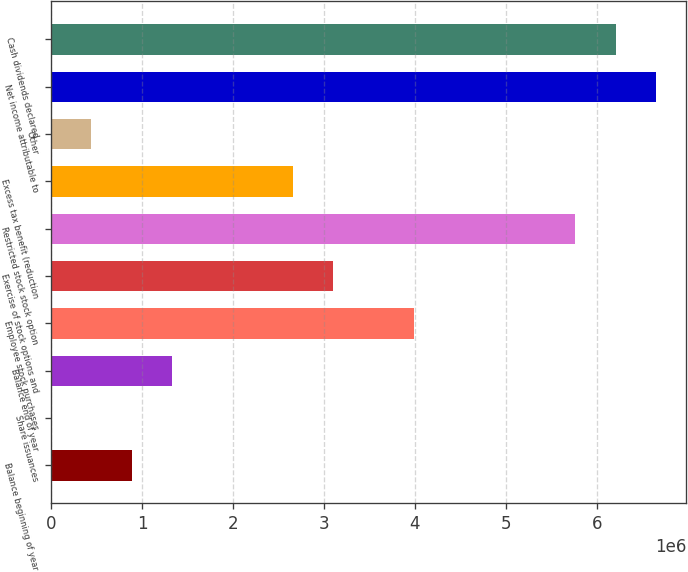Convert chart. <chart><loc_0><loc_0><loc_500><loc_500><bar_chart><fcel>Balance beginning of year<fcel>Share issuances<fcel>Balance end of year<fcel>Employee stock purchases<fcel>Exercise of stock options and<fcel>Restricted stock stock option<fcel>Excess tax benefit (reduction<fcel>Other<fcel>Net income attributable to<fcel>Cash dividends declared<nl><fcel>886663<fcel>15<fcel>1.32999e+06<fcel>3.98993e+06<fcel>3.10328e+06<fcel>5.76323e+06<fcel>2.65996e+06<fcel>443339<fcel>6.64988e+06<fcel>6.20655e+06<nl></chart> 